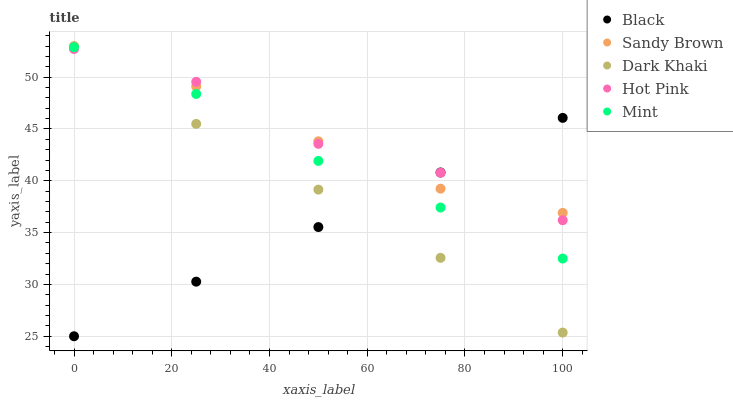Does Black have the minimum area under the curve?
Answer yes or no. Yes. Does Hot Pink have the maximum area under the curve?
Answer yes or no. Yes. Does Sandy Brown have the minimum area under the curve?
Answer yes or no. No. Does Sandy Brown have the maximum area under the curve?
Answer yes or no. No. Is Black the smoothest?
Answer yes or no. Yes. Is Hot Pink the roughest?
Answer yes or no. Yes. Is Sandy Brown the smoothest?
Answer yes or no. No. Is Sandy Brown the roughest?
Answer yes or no. No. Does Black have the lowest value?
Answer yes or no. Yes. Does Hot Pink have the lowest value?
Answer yes or no. No. Does Dark Khaki have the highest value?
Answer yes or no. Yes. Does Sandy Brown have the highest value?
Answer yes or no. No. Is Mint less than Sandy Brown?
Answer yes or no. Yes. Is Sandy Brown greater than Mint?
Answer yes or no. Yes. Does Dark Khaki intersect Sandy Brown?
Answer yes or no. Yes. Is Dark Khaki less than Sandy Brown?
Answer yes or no. No. Is Dark Khaki greater than Sandy Brown?
Answer yes or no. No. Does Mint intersect Sandy Brown?
Answer yes or no. No. 